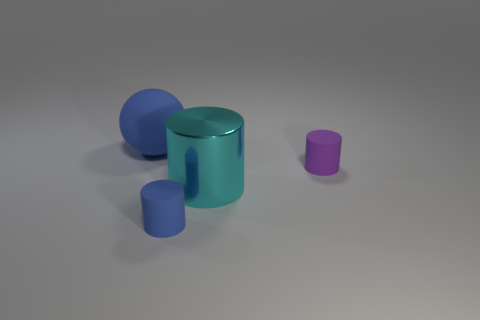Are there any other things that are the same material as the large cyan cylinder?
Offer a very short reply. No. Is there a object made of the same material as the blue sphere?
Give a very brief answer. Yes. Is the number of large yellow metallic objects greater than the number of large metal things?
Provide a succinct answer. No. Is the purple object made of the same material as the large sphere?
Keep it short and to the point. Yes. What number of matte things are big purple spheres or balls?
Make the answer very short. 1. There is another cylinder that is the same size as the blue cylinder; what is its color?
Make the answer very short. Purple. How many tiny objects are the same shape as the big shiny object?
Give a very brief answer. 2. What number of cylinders are tiny purple things or big rubber things?
Make the answer very short. 1. There is a blue thing that is in front of the cyan metal object; is it the same shape as the tiny rubber object to the right of the small blue thing?
Ensure brevity in your answer.  Yes. What material is the sphere?
Keep it short and to the point. Rubber. 